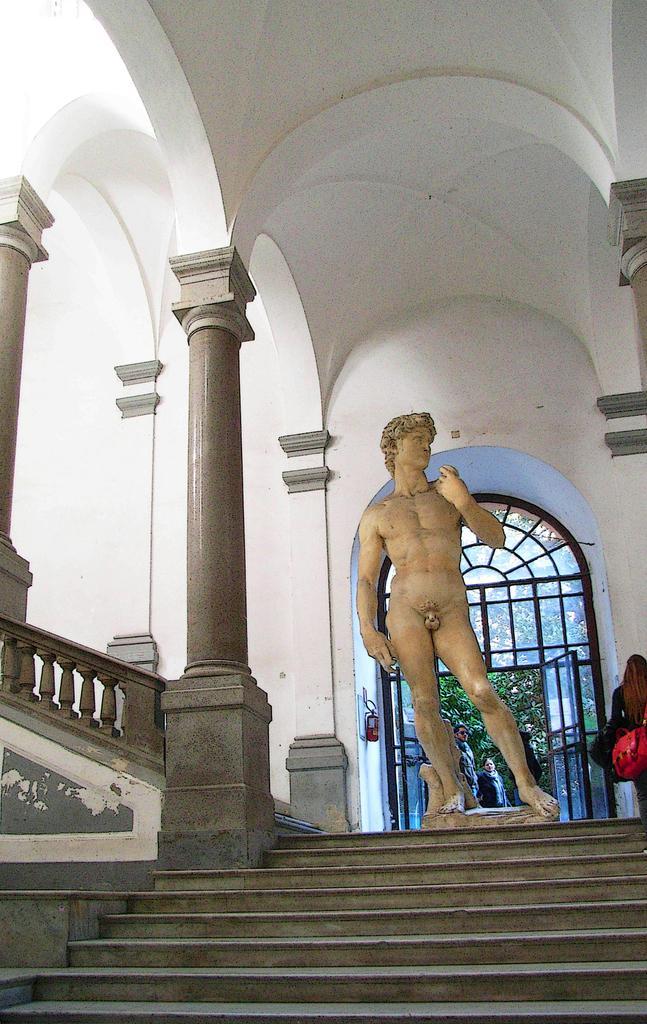Please provide a concise description of this image. This image consists of a statue. At the bottom, there are steps. On the left, there are pillars. At the top, there is a roof. On the right, there is a woman wearing a red bag. In the background, there are few persons. 